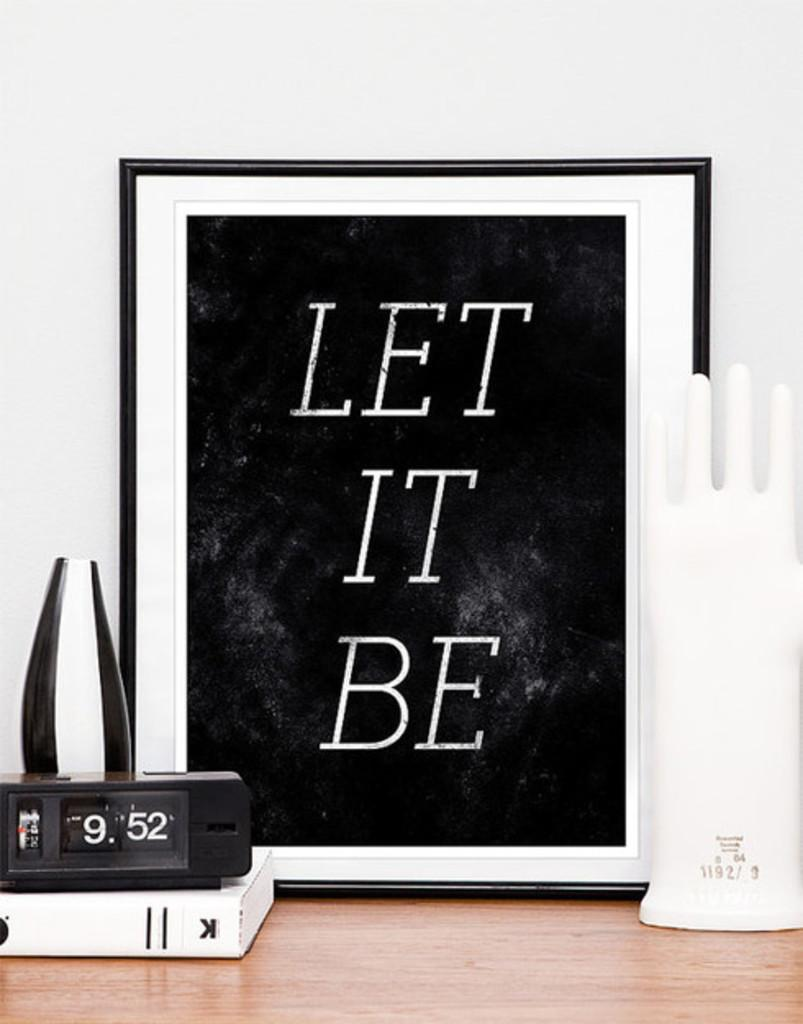<image>
Offer a succinct explanation of the picture presented. the words let it be are written on a black board 